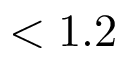Convert formula to latex. <formula><loc_0><loc_0><loc_500><loc_500>< 1 . 2</formula> 